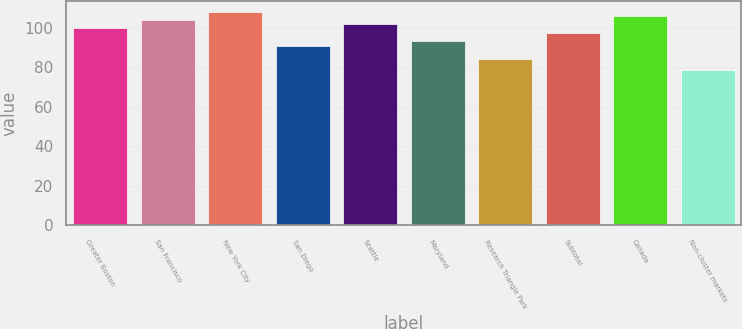Convert chart to OTSL. <chart><loc_0><loc_0><loc_500><loc_500><bar_chart><fcel>Greater Boston<fcel>San Francisco<fcel>New York City<fcel>San Diego<fcel>Seattle<fcel>Maryland<fcel>Research Triangle Park<fcel>Subtotal<fcel>Canada<fcel>Non-cluster markets<nl><fcel>99.62<fcel>103.9<fcel>108.18<fcel>90.9<fcel>101.76<fcel>93.2<fcel>84<fcel>97.48<fcel>106.04<fcel>78.4<nl></chart> 